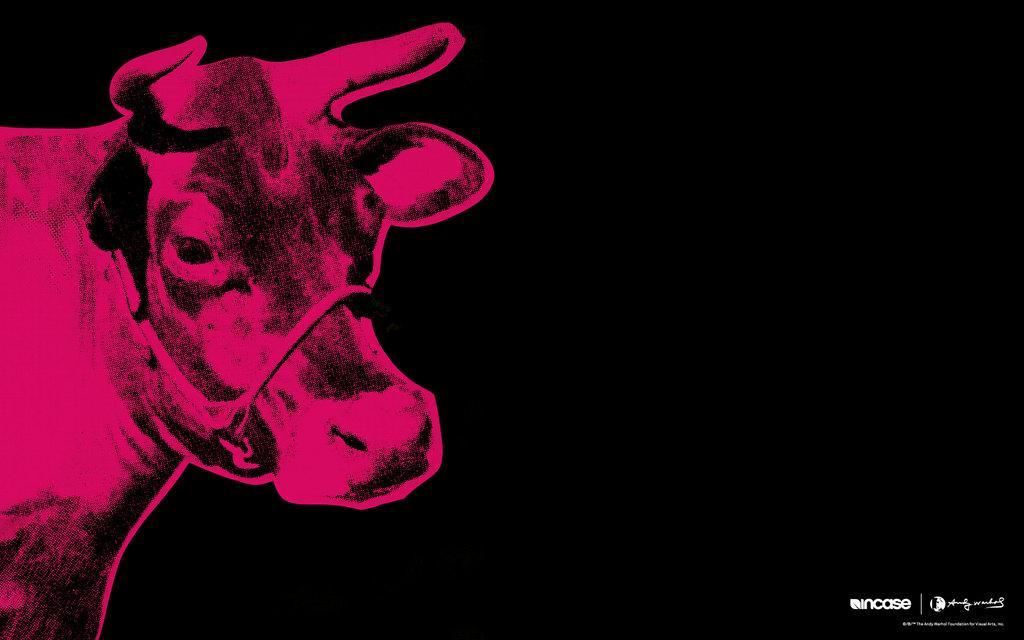How would you summarize this image in a sentence or two? In this image we can see the picture of an animal. 